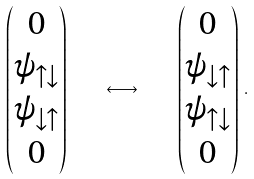Convert formula to latex. <formula><loc_0><loc_0><loc_500><loc_500>\left ( \begin{matrix} 0 \\ \psi _ { \uparrow \downarrow } \\ \psi _ { \downarrow \uparrow } \\ 0 \end{matrix} \right ) \quad \longleftrightarrow \quad \left ( \begin{matrix} 0 \\ \psi _ { \downarrow \uparrow } \\ \psi _ { \uparrow \downarrow } \\ 0 \end{matrix} \right ) \, .</formula> 